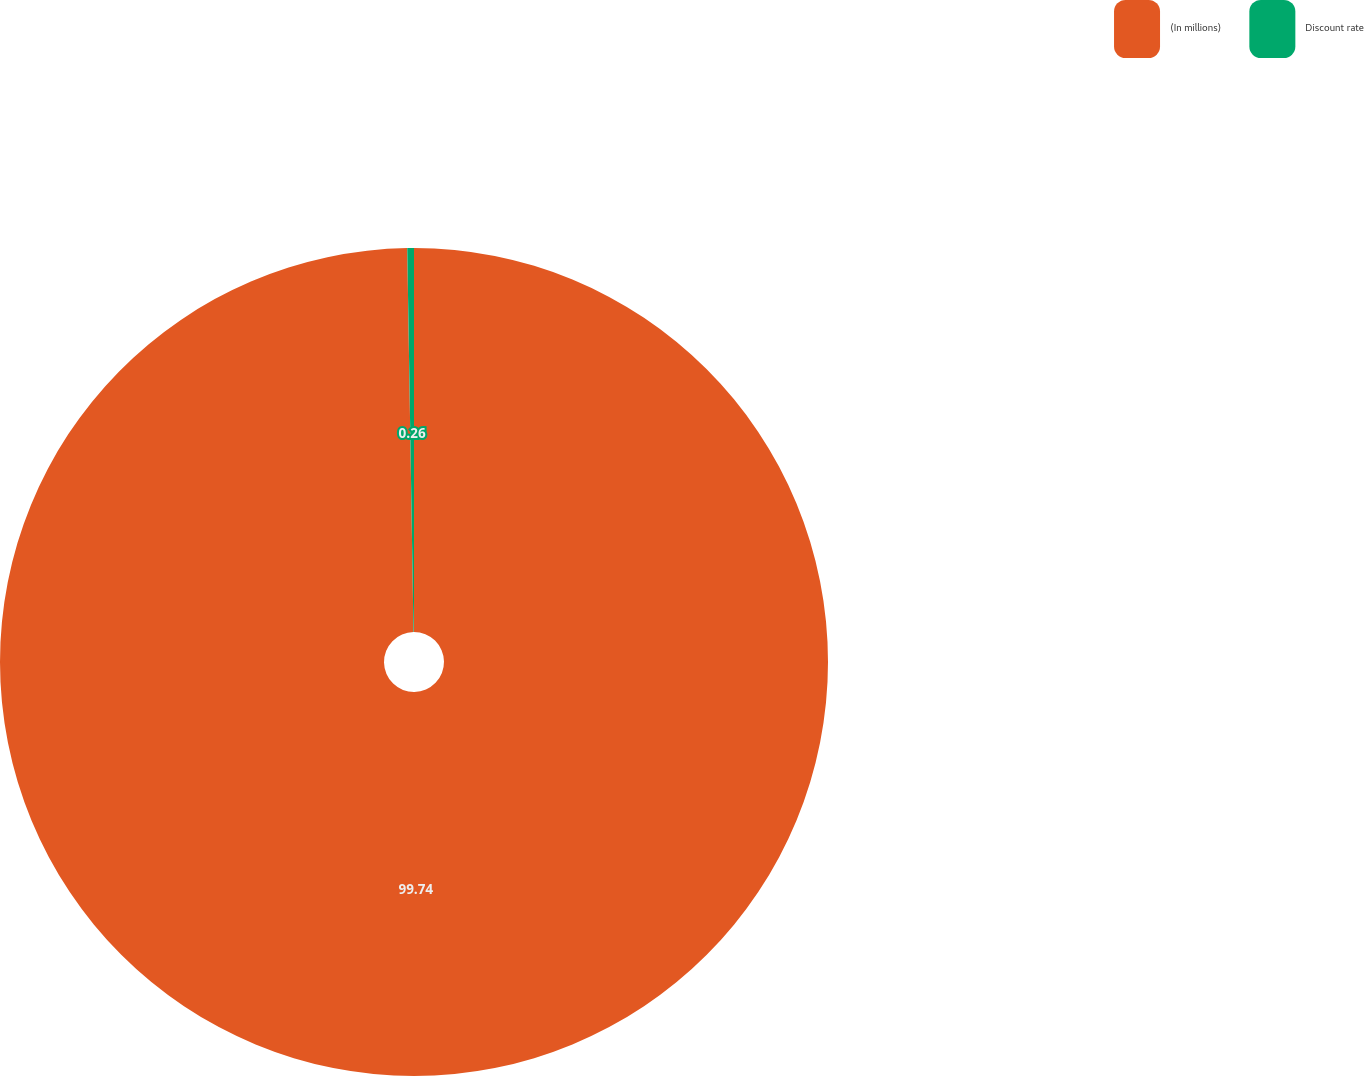Convert chart. <chart><loc_0><loc_0><loc_500><loc_500><pie_chart><fcel>(In millions)<fcel>Discount rate<nl><fcel>99.74%<fcel>0.26%<nl></chart> 